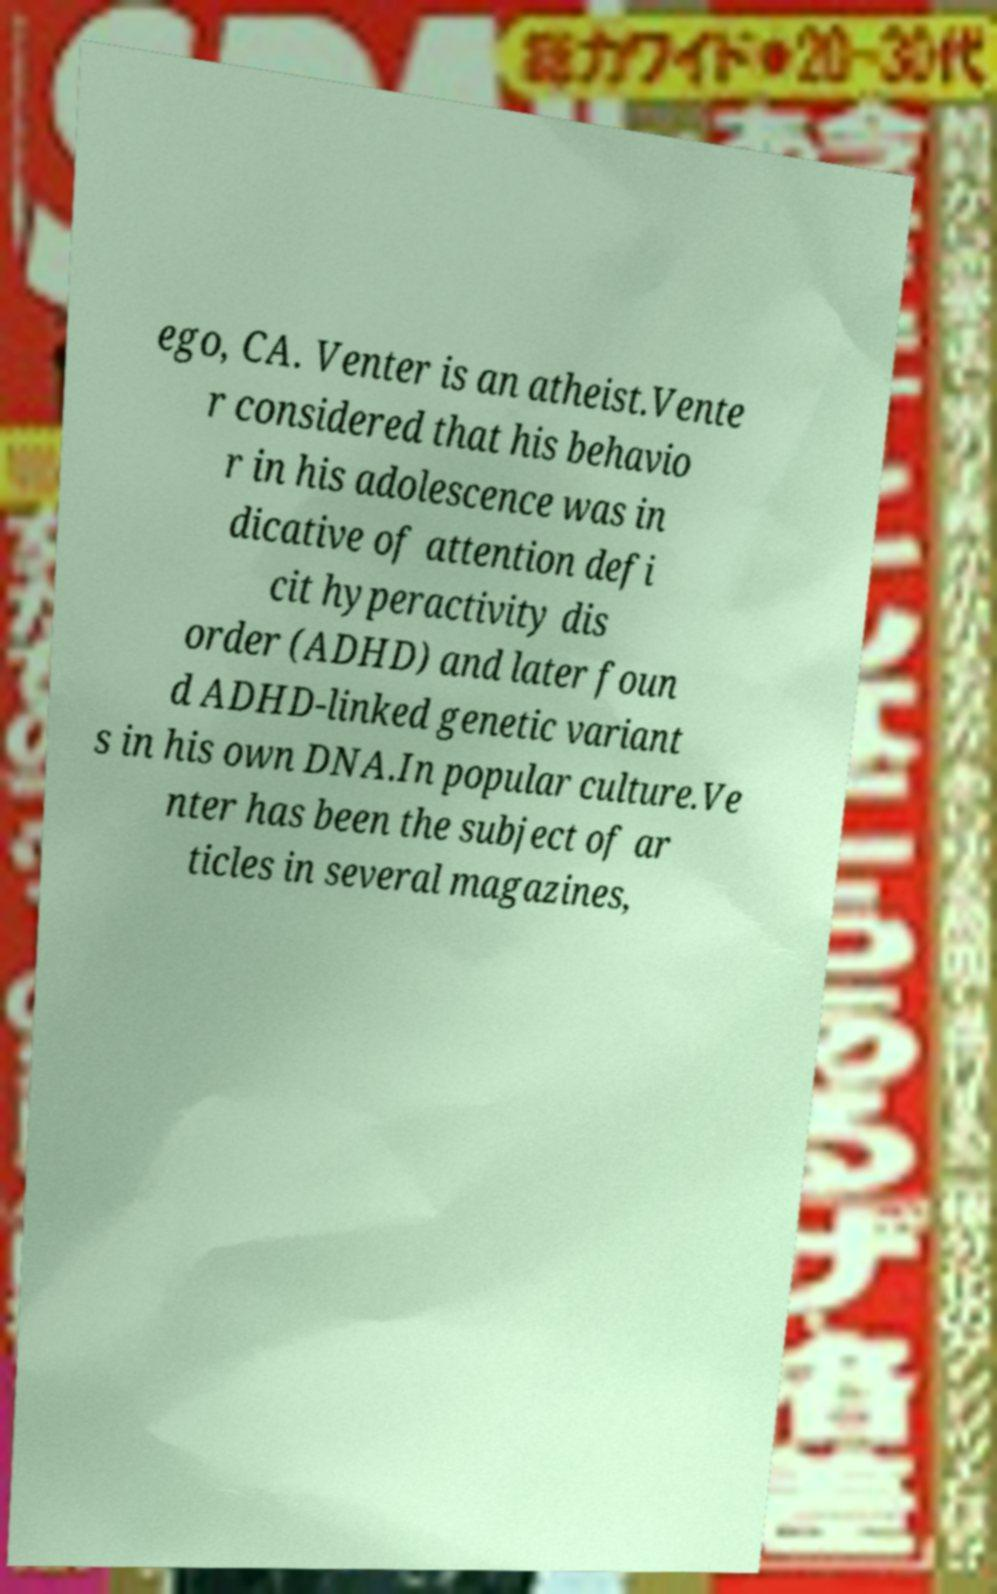I need the written content from this picture converted into text. Can you do that? ego, CA. Venter is an atheist.Vente r considered that his behavio r in his adolescence was in dicative of attention defi cit hyperactivity dis order (ADHD) and later foun d ADHD-linked genetic variant s in his own DNA.In popular culture.Ve nter has been the subject of ar ticles in several magazines, 